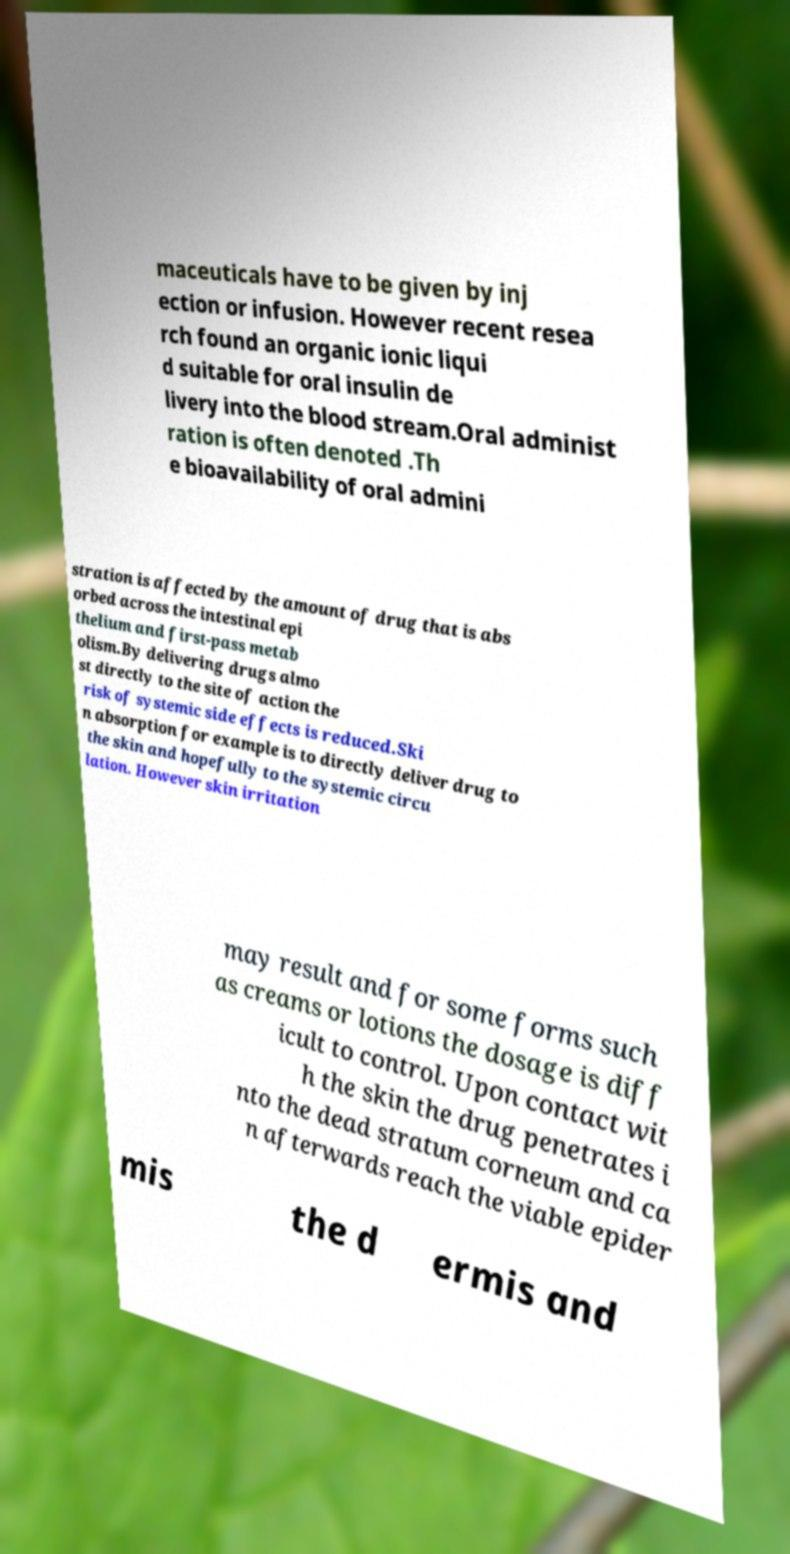Could you assist in decoding the text presented in this image and type it out clearly? maceuticals have to be given by inj ection or infusion. However recent resea rch found an organic ionic liqui d suitable for oral insulin de livery into the blood stream.Oral administ ration is often denoted .Th e bioavailability of oral admini stration is affected by the amount of drug that is abs orbed across the intestinal epi thelium and first-pass metab olism.By delivering drugs almo st directly to the site of action the risk of systemic side effects is reduced.Ski n absorption for example is to directly deliver drug to the skin and hopefully to the systemic circu lation. However skin irritation may result and for some forms such as creams or lotions the dosage is diff icult to control. Upon contact wit h the skin the drug penetrates i nto the dead stratum corneum and ca n afterwards reach the viable epider mis the d ermis and 